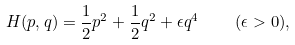Convert formula to latex. <formula><loc_0><loc_0><loc_500><loc_500>H ( p , q ) = { \frac { 1 } { 2 } } p ^ { 2 } + { \frac { 1 } { 2 } } q ^ { 2 } + \epsilon q ^ { 4 } \quad ( \epsilon > 0 ) ,</formula> 